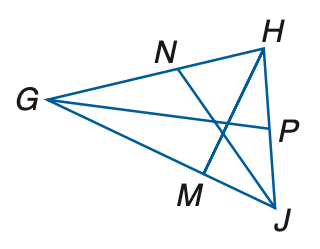Question: In \triangle G H J, H P = 5 x - 16, P J = 3 x + 8, m \angle G J N = 6 y - 3, m \angle N J H = 4 y + 23 and m \angle H M G = 4 z + 14. Find m \angle G J H if J N is an angle bisector.
Choices:
A. 60
B. 90
C. 120
D. 150
Answer with the letter. Answer: D Question: In \triangle G H J, H P = 5 x - 16, P J = 3 x + 8, m \angle G J N = 6 y - 3, m \angle N J H = 4 y + 23 and m \angle H M G = 4 z + 14. If H M is an altitude of \angle G H J, find the value of z.
Choices:
A. 16
B. 17
C. 18
D. 19
Answer with the letter. Answer: D 